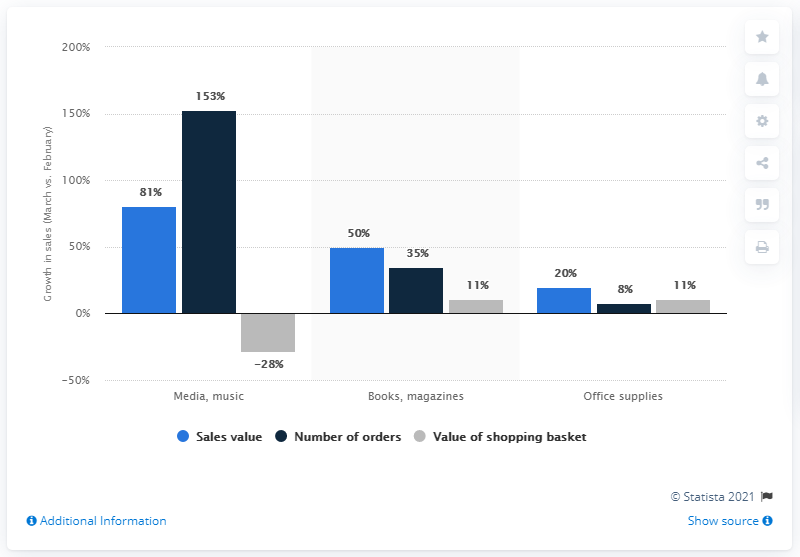Point out several critical features in this image. In March 2020, the amount of media and music orders increased by 153%. 